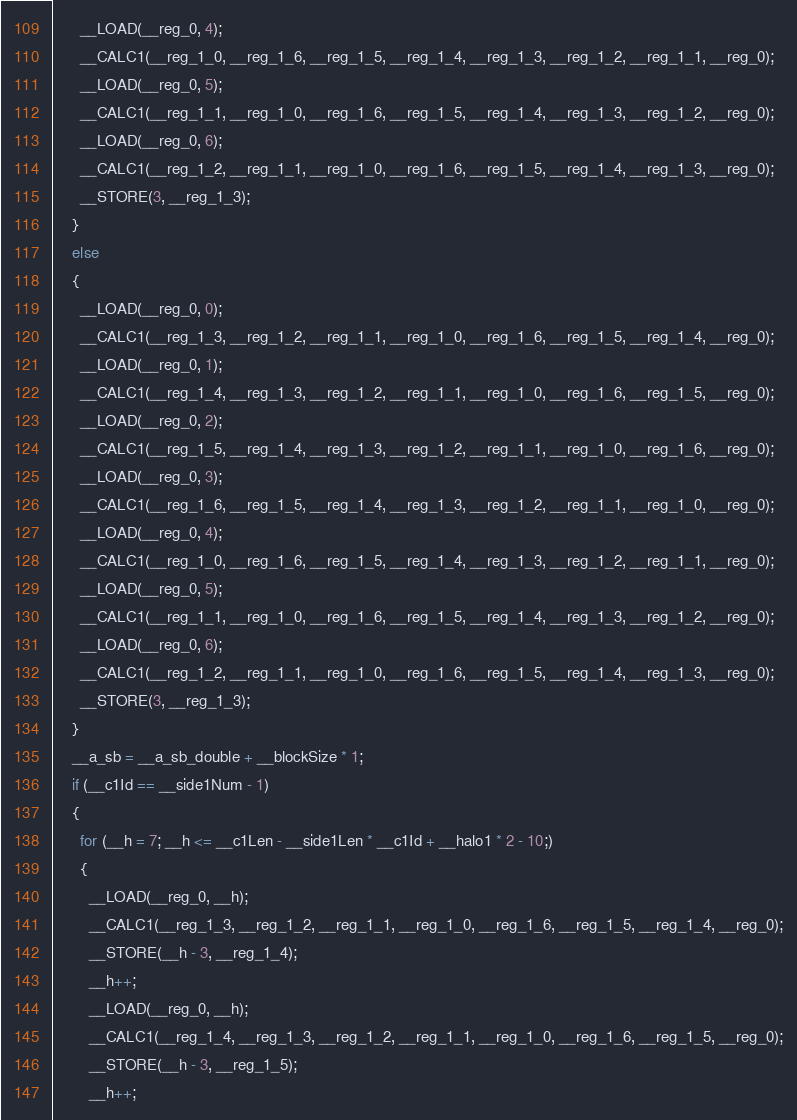Convert code to text. <code><loc_0><loc_0><loc_500><loc_500><_Cuda_>      __LOAD(__reg_0, 4);
      __CALC1(__reg_1_0, __reg_1_6, __reg_1_5, __reg_1_4, __reg_1_3, __reg_1_2, __reg_1_1, __reg_0);
      __LOAD(__reg_0, 5);
      __CALC1(__reg_1_1, __reg_1_0, __reg_1_6, __reg_1_5, __reg_1_4, __reg_1_3, __reg_1_2, __reg_0);
      __LOAD(__reg_0, 6);
      __CALC1(__reg_1_2, __reg_1_1, __reg_1_0, __reg_1_6, __reg_1_5, __reg_1_4, __reg_1_3, __reg_0);
      __STORE(3, __reg_1_3);
    }
    else
    {
      __LOAD(__reg_0, 0);
      __CALC1(__reg_1_3, __reg_1_2, __reg_1_1, __reg_1_0, __reg_1_6, __reg_1_5, __reg_1_4, __reg_0);
      __LOAD(__reg_0, 1);
      __CALC1(__reg_1_4, __reg_1_3, __reg_1_2, __reg_1_1, __reg_1_0, __reg_1_6, __reg_1_5, __reg_0);
      __LOAD(__reg_0, 2);
      __CALC1(__reg_1_5, __reg_1_4, __reg_1_3, __reg_1_2, __reg_1_1, __reg_1_0, __reg_1_6, __reg_0);
      __LOAD(__reg_0, 3);
      __CALC1(__reg_1_6, __reg_1_5, __reg_1_4, __reg_1_3, __reg_1_2, __reg_1_1, __reg_1_0, __reg_0);
      __LOAD(__reg_0, 4);
      __CALC1(__reg_1_0, __reg_1_6, __reg_1_5, __reg_1_4, __reg_1_3, __reg_1_2, __reg_1_1, __reg_0);
      __LOAD(__reg_0, 5);
      __CALC1(__reg_1_1, __reg_1_0, __reg_1_6, __reg_1_5, __reg_1_4, __reg_1_3, __reg_1_2, __reg_0);
      __LOAD(__reg_0, 6);
      __CALC1(__reg_1_2, __reg_1_1, __reg_1_0, __reg_1_6, __reg_1_5, __reg_1_4, __reg_1_3, __reg_0);
      __STORE(3, __reg_1_3);
    }
    __a_sb = __a_sb_double + __blockSize * 1;
    if (__c1Id == __side1Num - 1)
    {
      for (__h = 7; __h <= __c1Len - __side1Len * __c1Id + __halo1 * 2 - 10;)
      {
        __LOAD(__reg_0, __h);
        __CALC1(__reg_1_3, __reg_1_2, __reg_1_1, __reg_1_0, __reg_1_6, __reg_1_5, __reg_1_4, __reg_0);
        __STORE(__h - 3, __reg_1_4);
        __h++;
        __LOAD(__reg_0, __h);
        __CALC1(__reg_1_4, __reg_1_3, __reg_1_2, __reg_1_1, __reg_1_0, __reg_1_6, __reg_1_5, __reg_0);
        __STORE(__h - 3, __reg_1_5);
        __h++;</code> 